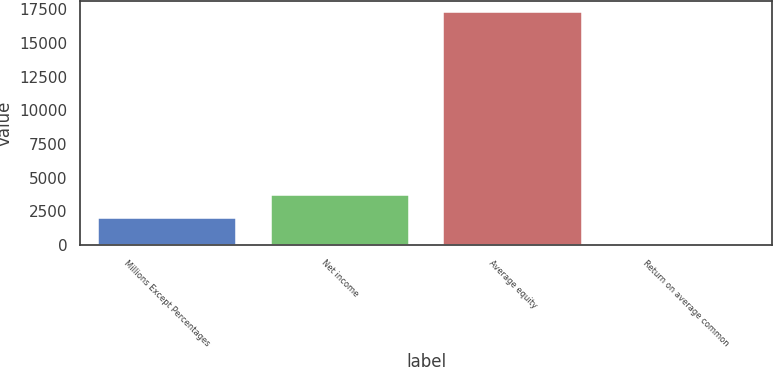<chart> <loc_0><loc_0><loc_500><loc_500><bar_chart><fcel>Millions Except Percentages<fcel>Net income<fcel>Average equity<fcel>Return on average common<nl><fcel>2010<fcel>3736.59<fcel>17282<fcel>16.1<nl></chart> 